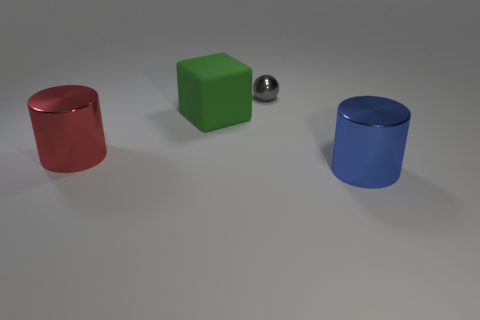Subtract all purple spheres. Subtract all brown blocks. How many spheres are left? 1 Add 4 big brown objects. How many objects exist? 8 Subtract all cubes. How many objects are left? 3 Subtract all large blue cylinders. Subtract all cubes. How many objects are left? 2 Add 3 red shiny things. How many red shiny things are left? 4 Add 3 tiny gray shiny objects. How many tiny gray shiny objects exist? 4 Subtract 0 blue balls. How many objects are left? 4 